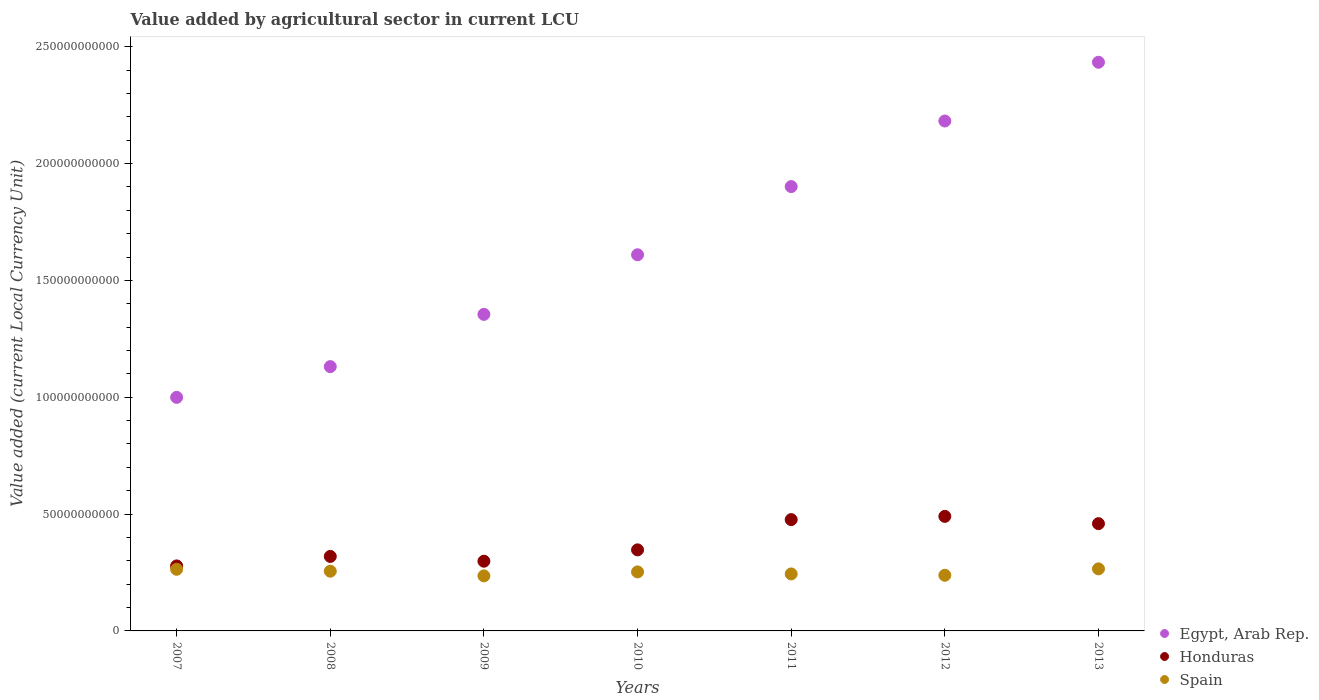How many different coloured dotlines are there?
Keep it short and to the point. 3. Is the number of dotlines equal to the number of legend labels?
Your answer should be compact. Yes. What is the value added by agricultural sector in Spain in 2012?
Provide a succinct answer. 2.38e+1. Across all years, what is the maximum value added by agricultural sector in Honduras?
Offer a very short reply. 4.90e+1. Across all years, what is the minimum value added by agricultural sector in Honduras?
Give a very brief answer. 2.78e+1. In which year was the value added by agricultural sector in Spain maximum?
Your answer should be compact. 2013. In which year was the value added by agricultural sector in Spain minimum?
Offer a very short reply. 2009. What is the total value added by agricultural sector in Egypt, Arab Rep. in the graph?
Your answer should be compact. 1.16e+12. What is the difference between the value added by agricultural sector in Egypt, Arab Rep. in 2007 and that in 2012?
Your answer should be very brief. -1.18e+11. What is the difference between the value added by agricultural sector in Egypt, Arab Rep. in 2013 and the value added by agricultural sector in Spain in 2008?
Provide a succinct answer. 2.18e+11. What is the average value added by agricultural sector in Honduras per year?
Give a very brief answer. 3.81e+1. In the year 2010, what is the difference between the value added by agricultural sector in Egypt, Arab Rep. and value added by agricultural sector in Spain?
Ensure brevity in your answer.  1.36e+11. In how many years, is the value added by agricultural sector in Honduras greater than 220000000000 LCU?
Offer a terse response. 0. What is the ratio of the value added by agricultural sector in Honduras in 2010 to that in 2013?
Your answer should be compact. 0.76. What is the difference between the highest and the second highest value added by agricultural sector in Honduras?
Ensure brevity in your answer.  1.38e+09. What is the difference between the highest and the lowest value added by agricultural sector in Honduras?
Your answer should be compact. 2.12e+1. In how many years, is the value added by agricultural sector in Honduras greater than the average value added by agricultural sector in Honduras taken over all years?
Offer a terse response. 3. Is it the case that in every year, the sum of the value added by agricultural sector in Honduras and value added by agricultural sector in Egypt, Arab Rep.  is greater than the value added by agricultural sector in Spain?
Ensure brevity in your answer.  Yes. Is the value added by agricultural sector in Spain strictly greater than the value added by agricultural sector in Honduras over the years?
Provide a short and direct response. No. How many years are there in the graph?
Offer a very short reply. 7. What is the difference between two consecutive major ticks on the Y-axis?
Offer a terse response. 5.00e+1. Does the graph contain any zero values?
Make the answer very short. No. Where does the legend appear in the graph?
Ensure brevity in your answer.  Bottom right. How many legend labels are there?
Offer a terse response. 3. What is the title of the graph?
Your answer should be compact. Value added by agricultural sector in current LCU. Does "United Arab Emirates" appear as one of the legend labels in the graph?
Provide a succinct answer. No. What is the label or title of the X-axis?
Ensure brevity in your answer.  Years. What is the label or title of the Y-axis?
Your answer should be compact. Value added (current Local Currency Unit). What is the Value added (current Local Currency Unit) in Egypt, Arab Rep. in 2007?
Provide a succinct answer. 1.00e+11. What is the Value added (current Local Currency Unit) of Honduras in 2007?
Make the answer very short. 2.78e+1. What is the Value added (current Local Currency Unit) in Spain in 2007?
Keep it short and to the point. 2.64e+1. What is the Value added (current Local Currency Unit) in Egypt, Arab Rep. in 2008?
Provide a succinct answer. 1.13e+11. What is the Value added (current Local Currency Unit) in Honduras in 2008?
Offer a very short reply. 3.19e+1. What is the Value added (current Local Currency Unit) of Spain in 2008?
Your answer should be compact. 2.56e+1. What is the Value added (current Local Currency Unit) in Egypt, Arab Rep. in 2009?
Provide a short and direct response. 1.35e+11. What is the Value added (current Local Currency Unit) of Honduras in 2009?
Make the answer very short. 2.98e+1. What is the Value added (current Local Currency Unit) in Spain in 2009?
Offer a terse response. 2.35e+1. What is the Value added (current Local Currency Unit) of Egypt, Arab Rep. in 2010?
Provide a short and direct response. 1.61e+11. What is the Value added (current Local Currency Unit) in Honduras in 2010?
Your answer should be compact. 3.47e+1. What is the Value added (current Local Currency Unit) in Spain in 2010?
Keep it short and to the point. 2.53e+1. What is the Value added (current Local Currency Unit) of Egypt, Arab Rep. in 2011?
Your answer should be compact. 1.90e+11. What is the Value added (current Local Currency Unit) of Honduras in 2011?
Offer a terse response. 4.76e+1. What is the Value added (current Local Currency Unit) in Spain in 2011?
Provide a succinct answer. 2.44e+1. What is the Value added (current Local Currency Unit) of Egypt, Arab Rep. in 2012?
Your response must be concise. 2.18e+11. What is the Value added (current Local Currency Unit) in Honduras in 2012?
Make the answer very short. 4.90e+1. What is the Value added (current Local Currency Unit) in Spain in 2012?
Offer a terse response. 2.38e+1. What is the Value added (current Local Currency Unit) in Egypt, Arab Rep. in 2013?
Your response must be concise. 2.43e+11. What is the Value added (current Local Currency Unit) in Honduras in 2013?
Your answer should be very brief. 4.59e+1. What is the Value added (current Local Currency Unit) of Spain in 2013?
Offer a very short reply. 2.66e+1. Across all years, what is the maximum Value added (current Local Currency Unit) in Egypt, Arab Rep.?
Your response must be concise. 2.43e+11. Across all years, what is the maximum Value added (current Local Currency Unit) of Honduras?
Provide a short and direct response. 4.90e+1. Across all years, what is the maximum Value added (current Local Currency Unit) of Spain?
Make the answer very short. 2.66e+1. Across all years, what is the minimum Value added (current Local Currency Unit) in Egypt, Arab Rep.?
Keep it short and to the point. 1.00e+11. Across all years, what is the minimum Value added (current Local Currency Unit) of Honduras?
Make the answer very short. 2.78e+1. Across all years, what is the minimum Value added (current Local Currency Unit) in Spain?
Give a very brief answer. 2.35e+1. What is the total Value added (current Local Currency Unit) of Egypt, Arab Rep. in the graph?
Give a very brief answer. 1.16e+12. What is the total Value added (current Local Currency Unit) of Honduras in the graph?
Ensure brevity in your answer.  2.67e+11. What is the total Value added (current Local Currency Unit) in Spain in the graph?
Keep it short and to the point. 1.76e+11. What is the difference between the Value added (current Local Currency Unit) of Egypt, Arab Rep. in 2007 and that in 2008?
Ensure brevity in your answer.  -1.32e+1. What is the difference between the Value added (current Local Currency Unit) of Honduras in 2007 and that in 2008?
Keep it short and to the point. -4.06e+09. What is the difference between the Value added (current Local Currency Unit) in Spain in 2007 and that in 2008?
Offer a terse response. 8.15e+08. What is the difference between the Value added (current Local Currency Unit) in Egypt, Arab Rep. in 2007 and that in 2009?
Provide a succinct answer. -3.55e+1. What is the difference between the Value added (current Local Currency Unit) of Honduras in 2007 and that in 2009?
Your response must be concise. -2.02e+09. What is the difference between the Value added (current Local Currency Unit) of Spain in 2007 and that in 2009?
Your answer should be very brief. 2.83e+09. What is the difference between the Value added (current Local Currency Unit) of Egypt, Arab Rep. in 2007 and that in 2010?
Offer a terse response. -6.10e+1. What is the difference between the Value added (current Local Currency Unit) in Honduras in 2007 and that in 2010?
Give a very brief answer. -6.87e+09. What is the difference between the Value added (current Local Currency Unit) of Spain in 2007 and that in 2010?
Make the answer very short. 1.12e+09. What is the difference between the Value added (current Local Currency Unit) of Egypt, Arab Rep. in 2007 and that in 2011?
Make the answer very short. -9.02e+1. What is the difference between the Value added (current Local Currency Unit) in Honduras in 2007 and that in 2011?
Keep it short and to the point. -1.98e+1. What is the difference between the Value added (current Local Currency Unit) of Spain in 2007 and that in 2011?
Your response must be concise. 1.98e+09. What is the difference between the Value added (current Local Currency Unit) in Egypt, Arab Rep. in 2007 and that in 2012?
Provide a succinct answer. -1.18e+11. What is the difference between the Value added (current Local Currency Unit) of Honduras in 2007 and that in 2012?
Your answer should be very brief. -2.12e+1. What is the difference between the Value added (current Local Currency Unit) in Spain in 2007 and that in 2012?
Your answer should be compact. 2.56e+09. What is the difference between the Value added (current Local Currency Unit) in Egypt, Arab Rep. in 2007 and that in 2013?
Ensure brevity in your answer.  -1.43e+11. What is the difference between the Value added (current Local Currency Unit) in Honduras in 2007 and that in 2013?
Keep it short and to the point. -1.81e+1. What is the difference between the Value added (current Local Currency Unit) in Spain in 2007 and that in 2013?
Provide a succinct answer. -1.84e+08. What is the difference between the Value added (current Local Currency Unit) of Egypt, Arab Rep. in 2008 and that in 2009?
Ensure brevity in your answer.  -2.24e+1. What is the difference between the Value added (current Local Currency Unit) in Honduras in 2008 and that in 2009?
Give a very brief answer. 2.05e+09. What is the difference between the Value added (current Local Currency Unit) in Spain in 2008 and that in 2009?
Your answer should be very brief. 2.01e+09. What is the difference between the Value added (current Local Currency Unit) in Egypt, Arab Rep. in 2008 and that in 2010?
Ensure brevity in your answer.  -4.79e+1. What is the difference between the Value added (current Local Currency Unit) in Honduras in 2008 and that in 2010?
Give a very brief answer. -2.81e+09. What is the difference between the Value added (current Local Currency Unit) in Spain in 2008 and that in 2010?
Keep it short and to the point. 3.08e+08. What is the difference between the Value added (current Local Currency Unit) of Egypt, Arab Rep. in 2008 and that in 2011?
Offer a very short reply. -7.71e+1. What is the difference between the Value added (current Local Currency Unit) of Honduras in 2008 and that in 2011?
Give a very brief answer. -1.58e+1. What is the difference between the Value added (current Local Currency Unit) in Spain in 2008 and that in 2011?
Offer a terse response. 1.17e+09. What is the difference between the Value added (current Local Currency Unit) of Egypt, Arab Rep. in 2008 and that in 2012?
Your response must be concise. -1.05e+11. What is the difference between the Value added (current Local Currency Unit) of Honduras in 2008 and that in 2012?
Your answer should be very brief. -1.71e+1. What is the difference between the Value added (current Local Currency Unit) in Spain in 2008 and that in 2012?
Provide a short and direct response. 1.74e+09. What is the difference between the Value added (current Local Currency Unit) in Egypt, Arab Rep. in 2008 and that in 2013?
Ensure brevity in your answer.  -1.30e+11. What is the difference between the Value added (current Local Currency Unit) of Honduras in 2008 and that in 2013?
Offer a very short reply. -1.40e+1. What is the difference between the Value added (current Local Currency Unit) of Spain in 2008 and that in 2013?
Offer a terse response. -9.99e+08. What is the difference between the Value added (current Local Currency Unit) of Egypt, Arab Rep. in 2009 and that in 2010?
Your answer should be compact. -2.55e+1. What is the difference between the Value added (current Local Currency Unit) of Honduras in 2009 and that in 2010?
Make the answer very short. -4.85e+09. What is the difference between the Value added (current Local Currency Unit) in Spain in 2009 and that in 2010?
Keep it short and to the point. -1.70e+09. What is the difference between the Value added (current Local Currency Unit) in Egypt, Arab Rep. in 2009 and that in 2011?
Provide a short and direct response. -5.47e+1. What is the difference between the Value added (current Local Currency Unit) of Honduras in 2009 and that in 2011?
Keep it short and to the point. -1.78e+1. What is the difference between the Value added (current Local Currency Unit) of Spain in 2009 and that in 2011?
Your answer should be compact. -8.42e+08. What is the difference between the Value added (current Local Currency Unit) in Egypt, Arab Rep. in 2009 and that in 2012?
Your response must be concise. -8.28e+1. What is the difference between the Value added (current Local Currency Unit) in Honduras in 2009 and that in 2012?
Ensure brevity in your answer.  -1.92e+1. What is the difference between the Value added (current Local Currency Unit) of Spain in 2009 and that in 2012?
Your answer should be very brief. -2.68e+08. What is the difference between the Value added (current Local Currency Unit) in Egypt, Arab Rep. in 2009 and that in 2013?
Ensure brevity in your answer.  -1.08e+11. What is the difference between the Value added (current Local Currency Unit) of Honduras in 2009 and that in 2013?
Provide a short and direct response. -1.61e+1. What is the difference between the Value added (current Local Currency Unit) in Spain in 2009 and that in 2013?
Your answer should be very brief. -3.01e+09. What is the difference between the Value added (current Local Currency Unit) of Egypt, Arab Rep. in 2010 and that in 2011?
Provide a succinct answer. -2.92e+1. What is the difference between the Value added (current Local Currency Unit) in Honduras in 2010 and that in 2011?
Make the answer very short. -1.29e+1. What is the difference between the Value added (current Local Currency Unit) in Spain in 2010 and that in 2011?
Make the answer very short. 8.62e+08. What is the difference between the Value added (current Local Currency Unit) in Egypt, Arab Rep. in 2010 and that in 2012?
Your answer should be very brief. -5.72e+1. What is the difference between the Value added (current Local Currency Unit) of Honduras in 2010 and that in 2012?
Offer a terse response. -1.43e+1. What is the difference between the Value added (current Local Currency Unit) in Spain in 2010 and that in 2012?
Provide a short and direct response. 1.44e+09. What is the difference between the Value added (current Local Currency Unit) of Egypt, Arab Rep. in 2010 and that in 2013?
Your response must be concise. -8.24e+1. What is the difference between the Value added (current Local Currency Unit) in Honduras in 2010 and that in 2013?
Make the answer very short. -1.12e+1. What is the difference between the Value added (current Local Currency Unit) in Spain in 2010 and that in 2013?
Give a very brief answer. -1.31e+09. What is the difference between the Value added (current Local Currency Unit) of Egypt, Arab Rep. in 2011 and that in 2012?
Your response must be concise. -2.81e+1. What is the difference between the Value added (current Local Currency Unit) of Honduras in 2011 and that in 2012?
Your response must be concise. -1.38e+09. What is the difference between the Value added (current Local Currency Unit) of Spain in 2011 and that in 2012?
Offer a terse response. 5.74e+08. What is the difference between the Value added (current Local Currency Unit) in Egypt, Arab Rep. in 2011 and that in 2013?
Offer a very short reply. -5.32e+1. What is the difference between the Value added (current Local Currency Unit) in Honduras in 2011 and that in 2013?
Your response must be concise. 1.74e+09. What is the difference between the Value added (current Local Currency Unit) of Spain in 2011 and that in 2013?
Your answer should be compact. -2.17e+09. What is the difference between the Value added (current Local Currency Unit) of Egypt, Arab Rep. in 2012 and that in 2013?
Make the answer very short. -2.51e+1. What is the difference between the Value added (current Local Currency Unit) of Honduras in 2012 and that in 2013?
Give a very brief answer. 3.12e+09. What is the difference between the Value added (current Local Currency Unit) in Spain in 2012 and that in 2013?
Ensure brevity in your answer.  -2.74e+09. What is the difference between the Value added (current Local Currency Unit) of Egypt, Arab Rep. in 2007 and the Value added (current Local Currency Unit) of Honduras in 2008?
Offer a very short reply. 6.81e+1. What is the difference between the Value added (current Local Currency Unit) in Egypt, Arab Rep. in 2007 and the Value added (current Local Currency Unit) in Spain in 2008?
Your answer should be very brief. 7.44e+1. What is the difference between the Value added (current Local Currency Unit) of Honduras in 2007 and the Value added (current Local Currency Unit) of Spain in 2008?
Your answer should be compact. 2.26e+09. What is the difference between the Value added (current Local Currency Unit) in Egypt, Arab Rep. in 2007 and the Value added (current Local Currency Unit) in Honduras in 2009?
Ensure brevity in your answer.  7.01e+1. What is the difference between the Value added (current Local Currency Unit) of Egypt, Arab Rep. in 2007 and the Value added (current Local Currency Unit) of Spain in 2009?
Provide a short and direct response. 7.64e+1. What is the difference between the Value added (current Local Currency Unit) of Honduras in 2007 and the Value added (current Local Currency Unit) of Spain in 2009?
Your answer should be very brief. 4.27e+09. What is the difference between the Value added (current Local Currency Unit) in Egypt, Arab Rep. in 2007 and the Value added (current Local Currency Unit) in Honduras in 2010?
Your answer should be very brief. 6.53e+1. What is the difference between the Value added (current Local Currency Unit) in Egypt, Arab Rep. in 2007 and the Value added (current Local Currency Unit) in Spain in 2010?
Your response must be concise. 7.47e+1. What is the difference between the Value added (current Local Currency Unit) of Honduras in 2007 and the Value added (current Local Currency Unit) of Spain in 2010?
Provide a succinct answer. 2.57e+09. What is the difference between the Value added (current Local Currency Unit) of Egypt, Arab Rep. in 2007 and the Value added (current Local Currency Unit) of Honduras in 2011?
Provide a succinct answer. 5.23e+1. What is the difference between the Value added (current Local Currency Unit) in Egypt, Arab Rep. in 2007 and the Value added (current Local Currency Unit) in Spain in 2011?
Offer a very short reply. 7.56e+1. What is the difference between the Value added (current Local Currency Unit) of Honduras in 2007 and the Value added (current Local Currency Unit) of Spain in 2011?
Provide a short and direct response. 3.43e+09. What is the difference between the Value added (current Local Currency Unit) of Egypt, Arab Rep. in 2007 and the Value added (current Local Currency Unit) of Honduras in 2012?
Your answer should be compact. 5.09e+1. What is the difference between the Value added (current Local Currency Unit) in Egypt, Arab Rep. in 2007 and the Value added (current Local Currency Unit) in Spain in 2012?
Offer a very short reply. 7.61e+1. What is the difference between the Value added (current Local Currency Unit) of Honduras in 2007 and the Value added (current Local Currency Unit) of Spain in 2012?
Your answer should be compact. 4.00e+09. What is the difference between the Value added (current Local Currency Unit) in Egypt, Arab Rep. in 2007 and the Value added (current Local Currency Unit) in Honduras in 2013?
Keep it short and to the point. 5.40e+1. What is the difference between the Value added (current Local Currency Unit) in Egypt, Arab Rep. in 2007 and the Value added (current Local Currency Unit) in Spain in 2013?
Keep it short and to the point. 7.34e+1. What is the difference between the Value added (current Local Currency Unit) of Honduras in 2007 and the Value added (current Local Currency Unit) of Spain in 2013?
Your response must be concise. 1.26e+09. What is the difference between the Value added (current Local Currency Unit) in Egypt, Arab Rep. in 2008 and the Value added (current Local Currency Unit) in Honduras in 2009?
Your answer should be very brief. 8.33e+1. What is the difference between the Value added (current Local Currency Unit) in Egypt, Arab Rep. in 2008 and the Value added (current Local Currency Unit) in Spain in 2009?
Ensure brevity in your answer.  8.96e+1. What is the difference between the Value added (current Local Currency Unit) in Honduras in 2008 and the Value added (current Local Currency Unit) in Spain in 2009?
Your response must be concise. 8.34e+09. What is the difference between the Value added (current Local Currency Unit) in Egypt, Arab Rep. in 2008 and the Value added (current Local Currency Unit) in Honduras in 2010?
Your response must be concise. 7.84e+1. What is the difference between the Value added (current Local Currency Unit) of Egypt, Arab Rep. in 2008 and the Value added (current Local Currency Unit) of Spain in 2010?
Keep it short and to the point. 8.79e+1. What is the difference between the Value added (current Local Currency Unit) in Honduras in 2008 and the Value added (current Local Currency Unit) in Spain in 2010?
Your answer should be very brief. 6.63e+09. What is the difference between the Value added (current Local Currency Unit) of Egypt, Arab Rep. in 2008 and the Value added (current Local Currency Unit) of Honduras in 2011?
Provide a short and direct response. 6.55e+1. What is the difference between the Value added (current Local Currency Unit) of Egypt, Arab Rep. in 2008 and the Value added (current Local Currency Unit) of Spain in 2011?
Give a very brief answer. 8.87e+1. What is the difference between the Value added (current Local Currency Unit) in Honduras in 2008 and the Value added (current Local Currency Unit) in Spain in 2011?
Ensure brevity in your answer.  7.49e+09. What is the difference between the Value added (current Local Currency Unit) of Egypt, Arab Rep. in 2008 and the Value added (current Local Currency Unit) of Honduras in 2012?
Your answer should be compact. 6.41e+1. What is the difference between the Value added (current Local Currency Unit) in Egypt, Arab Rep. in 2008 and the Value added (current Local Currency Unit) in Spain in 2012?
Keep it short and to the point. 8.93e+1. What is the difference between the Value added (current Local Currency Unit) in Honduras in 2008 and the Value added (current Local Currency Unit) in Spain in 2012?
Your answer should be very brief. 8.07e+09. What is the difference between the Value added (current Local Currency Unit) of Egypt, Arab Rep. in 2008 and the Value added (current Local Currency Unit) of Honduras in 2013?
Give a very brief answer. 6.72e+1. What is the difference between the Value added (current Local Currency Unit) of Egypt, Arab Rep. in 2008 and the Value added (current Local Currency Unit) of Spain in 2013?
Your answer should be very brief. 8.65e+1. What is the difference between the Value added (current Local Currency Unit) of Honduras in 2008 and the Value added (current Local Currency Unit) of Spain in 2013?
Your response must be concise. 5.32e+09. What is the difference between the Value added (current Local Currency Unit) of Egypt, Arab Rep. in 2009 and the Value added (current Local Currency Unit) of Honduras in 2010?
Keep it short and to the point. 1.01e+11. What is the difference between the Value added (current Local Currency Unit) of Egypt, Arab Rep. in 2009 and the Value added (current Local Currency Unit) of Spain in 2010?
Provide a succinct answer. 1.10e+11. What is the difference between the Value added (current Local Currency Unit) in Honduras in 2009 and the Value added (current Local Currency Unit) in Spain in 2010?
Ensure brevity in your answer.  4.58e+09. What is the difference between the Value added (current Local Currency Unit) in Egypt, Arab Rep. in 2009 and the Value added (current Local Currency Unit) in Honduras in 2011?
Your answer should be compact. 8.78e+1. What is the difference between the Value added (current Local Currency Unit) of Egypt, Arab Rep. in 2009 and the Value added (current Local Currency Unit) of Spain in 2011?
Your response must be concise. 1.11e+11. What is the difference between the Value added (current Local Currency Unit) of Honduras in 2009 and the Value added (current Local Currency Unit) of Spain in 2011?
Provide a succinct answer. 5.45e+09. What is the difference between the Value added (current Local Currency Unit) of Egypt, Arab Rep. in 2009 and the Value added (current Local Currency Unit) of Honduras in 2012?
Offer a very short reply. 8.64e+1. What is the difference between the Value added (current Local Currency Unit) of Egypt, Arab Rep. in 2009 and the Value added (current Local Currency Unit) of Spain in 2012?
Your response must be concise. 1.12e+11. What is the difference between the Value added (current Local Currency Unit) in Honduras in 2009 and the Value added (current Local Currency Unit) in Spain in 2012?
Ensure brevity in your answer.  6.02e+09. What is the difference between the Value added (current Local Currency Unit) in Egypt, Arab Rep. in 2009 and the Value added (current Local Currency Unit) in Honduras in 2013?
Your answer should be very brief. 8.96e+1. What is the difference between the Value added (current Local Currency Unit) in Egypt, Arab Rep. in 2009 and the Value added (current Local Currency Unit) in Spain in 2013?
Offer a terse response. 1.09e+11. What is the difference between the Value added (current Local Currency Unit) in Honduras in 2009 and the Value added (current Local Currency Unit) in Spain in 2013?
Provide a succinct answer. 3.28e+09. What is the difference between the Value added (current Local Currency Unit) of Egypt, Arab Rep. in 2010 and the Value added (current Local Currency Unit) of Honduras in 2011?
Offer a terse response. 1.13e+11. What is the difference between the Value added (current Local Currency Unit) of Egypt, Arab Rep. in 2010 and the Value added (current Local Currency Unit) of Spain in 2011?
Ensure brevity in your answer.  1.37e+11. What is the difference between the Value added (current Local Currency Unit) in Honduras in 2010 and the Value added (current Local Currency Unit) in Spain in 2011?
Ensure brevity in your answer.  1.03e+1. What is the difference between the Value added (current Local Currency Unit) in Egypt, Arab Rep. in 2010 and the Value added (current Local Currency Unit) in Honduras in 2012?
Provide a succinct answer. 1.12e+11. What is the difference between the Value added (current Local Currency Unit) in Egypt, Arab Rep. in 2010 and the Value added (current Local Currency Unit) in Spain in 2012?
Ensure brevity in your answer.  1.37e+11. What is the difference between the Value added (current Local Currency Unit) of Honduras in 2010 and the Value added (current Local Currency Unit) of Spain in 2012?
Ensure brevity in your answer.  1.09e+1. What is the difference between the Value added (current Local Currency Unit) in Egypt, Arab Rep. in 2010 and the Value added (current Local Currency Unit) in Honduras in 2013?
Provide a succinct answer. 1.15e+11. What is the difference between the Value added (current Local Currency Unit) in Egypt, Arab Rep. in 2010 and the Value added (current Local Currency Unit) in Spain in 2013?
Keep it short and to the point. 1.34e+11. What is the difference between the Value added (current Local Currency Unit) of Honduras in 2010 and the Value added (current Local Currency Unit) of Spain in 2013?
Offer a terse response. 8.13e+09. What is the difference between the Value added (current Local Currency Unit) of Egypt, Arab Rep. in 2011 and the Value added (current Local Currency Unit) of Honduras in 2012?
Make the answer very short. 1.41e+11. What is the difference between the Value added (current Local Currency Unit) in Egypt, Arab Rep. in 2011 and the Value added (current Local Currency Unit) in Spain in 2012?
Keep it short and to the point. 1.66e+11. What is the difference between the Value added (current Local Currency Unit) in Honduras in 2011 and the Value added (current Local Currency Unit) in Spain in 2012?
Offer a terse response. 2.38e+1. What is the difference between the Value added (current Local Currency Unit) in Egypt, Arab Rep. in 2011 and the Value added (current Local Currency Unit) in Honduras in 2013?
Provide a short and direct response. 1.44e+11. What is the difference between the Value added (current Local Currency Unit) of Egypt, Arab Rep. in 2011 and the Value added (current Local Currency Unit) of Spain in 2013?
Your response must be concise. 1.64e+11. What is the difference between the Value added (current Local Currency Unit) of Honduras in 2011 and the Value added (current Local Currency Unit) of Spain in 2013?
Your answer should be compact. 2.11e+1. What is the difference between the Value added (current Local Currency Unit) in Egypt, Arab Rep. in 2012 and the Value added (current Local Currency Unit) in Honduras in 2013?
Keep it short and to the point. 1.72e+11. What is the difference between the Value added (current Local Currency Unit) in Egypt, Arab Rep. in 2012 and the Value added (current Local Currency Unit) in Spain in 2013?
Provide a succinct answer. 1.92e+11. What is the difference between the Value added (current Local Currency Unit) in Honduras in 2012 and the Value added (current Local Currency Unit) in Spain in 2013?
Your response must be concise. 2.25e+1. What is the average Value added (current Local Currency Unit) in Egypt, Arab Rep. per year?
Make the answer very short. 1.66e+11. What is the average Value added (current Local Currency Unit) in Honduras per year?
Your answer should be very brief. 3.81e+1. What is the average Value added (current Local Currency Unit) of Spain per year?
Provide a short and direct response. 2.51e+1. In the year 2007, what is the difference between the Value added (current Local Currency Unit) of Egypt, Arab Rep. and Value added (current Local Currency Unit) of Honduras?
Offer a terse response. 7.21e+1. In the year 2007, what is the difference between the Value added (current Local Currency Unit) of Egypt, Arab Rep. and Value added (current Local Currency Unit) of Spain?
Ensure brevity in your answer.  7.36e+1. In the year 2007, what is the difference between the Value added (current Local Currency Unit) of Honduras and Value added (current Local Currency Unit) of Spain?
Offer a very short reply. 1.44e+09. In the year 2008, what is the difference between the Value added (current Local Currency Unit) of Egypt, Arab Rep. and Value added (current Local Currency Unit) of Honduras?
Give a very brief answer. 8.12e+1. In the year 2008, what is the difference between the Value added (current Local Currency Unit) of Egypt, Arab Rep. and Value added (current Local Currency Unit) of Spain?
Give a very brief answer. 8.75e+1. In the year 2008, what is the difference between the Value added (current Local Currency Unit) of Honduras and Value added (current Local Currency Unit) of Spain?
Your response must be concise. 6.32e+09. In the year 2009, what is the difference between the Value added (current Local Currency Unit) in Egypt, Arab Rep. and Value added (current Local Currency Unit) in Honduras?
Your answer should be very brief. 1.06e+11. In the year 2009, what is the difference between the Value added (current Local Currency Unit) of Egypt, Arab Rep. and Value added (current Local Currency Unit) of Spain?
Keep it short and to the point. 1.12e+11. In the year 2009, what is the difference between the Value added (current Local Currency Unit) in Honduras and Value added (current Local Currency Unit) in Spain?
Your response must be concise. 6.29e+09. In the year 2010, what is the difference between the Value added (current Local Currency Unit) in Egypt, Arab Rep. and Value added (current Local Currency Unit) in Honduras?
Offer a very short reply. 1.26e+11. In the year 2010, what is the difference between the Value added (current Local Currency Unit) in Egypt, Arab Rep. and Value added (current Local Currency Unit) in Spain?
Ensure brevity in your answer.  1.36e+11. In the year 2010, what is the difference between the Value added (current Local Currency Unit) in Honduras and Value added (current Local Currency Unit) in Spain?
Keep it short and to the point. 9.44e+09. In the year 2011, what is the difference between the Value added (current Local Currency Unit) of Egypt, Arab Rep. and Value added (current Local Currency Unit) of Honduras?
Provide a succinct answer. 1.43e+11. In the year 2011, what is the difference between the Value added (current Local Currency Unit) of Egypt, Arab Rep. and Value added (current Local Currency Unit) of Spain?
Provide a succinct answer. 1.66e+11. In the year 2011, what is the difference between the Value added (current Local Currency Unit) of Honduras and Value added (current Local Currency Unit) of Spain?
Offer a terse response. 2.32e+1. In the year 2012, what is the difference between the Value added (current Local Currency Unit) of Egypt, Arab Rep. and Value added (current Local Currency Unit) of Honduras?
Your answer should be very brief. 1.69e+11. In the year 2012, what is the difference between the Value added (current Local Currency Unit) in Egypt, Arab Rep. and Value added (current Local Currency Unit) in Spain?
Provide a short and direct response. 1.94e+11. In the year 2012, what is the difference between the Value added (current Local Currency Unit) in Honduras and Value added (current Local Currency Unit) in Spain?
Your response must be concise. 2.52e+1. In the year 2013, what is the difference between the Value added (current Local Currency Unit) of Egypt, Arab Rep. and Value added (current Local Currency Unit) of Honduras?
Offer a terse response. 1.97e+11. In the year 2013, what is the difference between the Value added (current Local Currency Unit) in Egypt, Arab Rep. and Value added (current Local Currency Unit) in Spain?
Provide a short and direct response. 2.17e+11. In the year 2013, what is the difference between the Value added (current Local Currency Unit) in Honduras and Value added (current Local Currency Unit) in Spain?
Make the answer very short. 1.93e+1. What is the ratio of the Value added (current Local Currency Unit) of Egypt, Arab Rep. in 2007 to that in 2008?
Make the answer very short. 0.88. What is the ratio of the Value added (current Local Currency Unit) of Honduras in 2007 to that in 2008?
Your answer should be compact. 0.87. What is the ratio of the Value added (current Local Currency Unit) in Spain in 2007 to that in 2008?
Your answer should be compact. 1.03. What is the ratio of the Value added (current Local Currency Unit) in Egypt, Arab Rep. in 2007 to that in 2009?
Provide a succinct answer. 0.74. What is the ratio of the Value added (current Local Currency Unit) in Honduras in 2007 to that in 2009?
Ensure brevity in your answer.  0.93. What is the ratio of the Value added (current Local Currency Unit) of Spain in 2007 to that in 2009?
Offer a terse response. 1.12. What is the ratio of the Value added (current Local Currency Unit) of Egypt, Arab Rep. in 2007 to that in 2010?
Make the answer very short. 0.62. What is the ratio of the Value added (current Local Currency Unit) of Honduras in 2007 to that in 2010?
Provide a short and direct response. 0.8. What is the ratio of the Value added (current Local Currency Unit) in Spain in 2007 to that in 2010?
Make the answer very short. 1.04. What is the ratio of the Value added (current Local Currency Unit) of Egypt, Arab Rep. in 2007 to that in 2011?
Offer a very short reply. 0.53. What is the ratio of the Value added (current Local Currency Unit) of Honduras in 2007 to that in 2011?
Ensure brevity in your answer.  0.58. What is the ratio of the Value added (current Local Currency Unit) of Spain in 2007 to that in 2011?
Give a very brief answer. 1.08. What is the ratio of the Value added (current Local Currency Unit) of Egypt, Arab Rep. in 2007 to that in 2012?
Your answer should be very brief. 0.46. What is the ratio of the Value added (current Local Currency Unit) in Honduras in 2007 to that in 2012?
Give a very brief answer. 0.57. What is the ratio of the Value added (current Local Currency Unit) in Spain in 2007 to that in 2012?
Provide a short and direct response. 1.11. What is the ratio of the Value added (current Local Currency Unit) in Egypt, Arab Rep. in 2007 to that in 2013?
Make the answer very short. 0.41. What is the ratio of the Value added (current Local Currency Unit) of Honduras in 2007 to that in 2013?
Give a very brief answer. 0.61. What is the ratio of the Value added (current Local Currency Unit) in Spain in 2007 to that in 2013?
Keep it short and to the point. 0.99. What is the ratio of the Value added (current Local Currency Unit) in Egypt, Arab Rep. in 2008 to that in 2009?
Ensure brevity in your answer.  0.83. What is the ratio of the Value added (current Local Currency Unit) in Honduras in 2008 to that in 2009?
Keep it short and to the point. 1.07. What is the ratio of the Value added (current Local Currency Unit) of Spain in 2008 to that in 2009?
Ensure brevity in your answer.  1.09. What is the ratio of the Value added (current Local Currency Unit) of Egypt, Arab Rep. in 2008 to that in 2010?
Keep it short and to the point. 0.7. What is the ratio of the Value added (current Local Currency Unit) in Honduras in 2008 to that in 2010?
Your answer should be very brief. 0.92. What is the ratio of the Value added (current Local Currency Unit) in Spain in 2008 to that in 2010?
Your answer should be very brief. 1.01. What is the ratio of the Value added (current Local Currency Unit) of Egypt, Arab Rep. in 2008 to that in 2011?
Make the answer very short. 0.59. What is the ratio of the Value added (current Local Currency Unit) of Honduras in 2008 to that in 2011?
Make the answer very short. 0.67. What is the ratio of the Value added (current Local Currency Unit) in Spain in 2008 to that in 2011?
Your answer should be compact. 1.05. What is the ratio of the Value added (current Local Currency Unit) of Egypt, Arab Rep. in 2008 to that in 2012?
Your answer should be compact. 0.52. What is the ratio of the Value added (current Local Currency Unit) in Honduras in 2008 to that in 2012?
Your response must be concise. 0.65. What is the ratio of the Value added (current Local Currency Unit) in Spain in 2008 to that in 2012?
Give a very brief answer. 1.07. What is the ratio of the Value added (current Local Currency Unit) in Egypt, Arab Rep. in 2008 to that in 2013?
Ensure brevity in your answer.  0.46. What is the ratio of the Value added (current Local Currency Unit) of Honduras in 2008 to that in 2013?
Offer a terse response. 0.69. What is the ratio of the Value added (current Local Currency Unit) of Spain in 2008 to that in 2013?
Offer a terse response. 0.96. What is the ratio of the Value added (current Local Currency Unit) of Egypt, Arab Rep. in 2009 to that in 2010?
Your answer should be very brief. 0.84. What is the ratio of the Value added (current Local Currency Unit) in Honduras in 2009 to that in 2010?
Ensure brevity in your answer.  0.86. What is the ratio of the Value added (current Local Currency Unit) of Spain in 2009 to that in 2010?
Offer a very short reply. 0.93. What is the ratio of the Value added (current Local Currency Unit) of Egypt, Arab Rep. in 2009 to that in 2011?
Your response must be concise. 0.71. What is the ratio of the Value added (current Local Currency Unit) in Honduras in 2009 to that in 2011?
Offer a terse response. 0.63. What is the ratio of the Value added (current Local Currency Unit) in Spain in 2009 to that in 2011?
Your answer should be very brief. 0.97. What is the ratio of the Value added (current Local Currency Unit) of Egypt, Arab Rep. in 2009 to that in 2012?
Keep it short and to the point. 0.62. What is the ratio of the Value added (current Local Currency Unit) in Honduras in 2009 to that in 2012?
Your answer should be compact. 0.61. What is the ratio of the Value added (current Local Currency Unit) in Spain in 2009 to that in 2012?
Provide a succinct answer. 0.99. What is the ratio of the Value added (current Local Currency Unit) in Egypt, Arab Rep. in 2009 to that in 2013?
Offer a terse response. 0.56. What is the ratio of the Value added (current Local Currency Unit) of Honduras in 2009 to that in 2013?
Provide a succinct answer. 0.65. What is the ratio of the Value added (current Local Currency Unit) of Spain in 2009 to that in 2013?
Make the answer very short. 0.89. What is the ratio of the Value added (current Local Currency Unit) in Egypt, Arab Rep. in 2010 to that in 2011?
Make the answer very short. 0.85. What is the ratio of the Value added (current Local Currency Unit) of Honduras in 2010 to that in 2011?
Ensure brevity in your answer.  0.73. What is the ratio of the Value added (current Local Currency Unit) in Spain in 2010 to that in 2011?
Offer a very short reply. 1.04. What is the ratio of the Value added (current Local Currency Unit) in Egypt, Arab Rep. in 2010 to that in 2012?
Ensure brevity in your answer.  0.74. What is the ratio of the Value added (current Local Currency Unit) in Honduras in 2010 to that in 2012?
Your answer should be very brief. 0.71. What is the ratio of the Value added (current Local Currency Unit) in Spain in 2010 to that in 2012?
Ensure brevity in your answer.  1.06. What is the ratio of the Value added (current Local Currency Unit) of Egypt, Arab Rep. in 2010 to that in 2013?
Make the answer very short. 0.66. What is the ratio of the Value added (current Local Currency Unit) of Honduras in 2010 to that in 2013?
Provide a short and direct response. 0.76. What is the ratio of the Value added (current Local Currency Unit) of Spain in 2010 to that in 2013?
Your answer should be compact. 0.95. What is the ratio of the Value added (current Local Currency Unit) in Egypt, Arab Rep. in 2011 to that in 2012?
Offer a terse response. 0.87. What is the ratio of the Value added (current Local Currency Unit) of Honduras in 2011 to that in 2012?
Keep it short and to the point. 0.97. What is the ratio of the Value added (current Local Currency Unit) in Spain in 2011 to that in 2012?
Your answer should be compact. 1.02. What is the ratio of the Value added (current Local Currency Unit) of Egypt, Arab Rep. in 2011 to that in 2013?
Make the answer very short. 0.78. What is the ratio of the Value added (current Local Currency Unit) in Honduras in 2011 to that in 2013?
Give a very brief answer. 1.04. What is the ratio of the Value added (current Local Currency Unit) of Spain in 2011 to that in 2013?
Offer a very short reply. 0.92. What is the ratio of the Value added (current Local Currency Unit) in Egypt, Arab Rep. in 2012 to that in 2013?
Keep it short and to the point. 0.9. What is the ratio of the Value added (current Local Currency Unit) in Honduras in 2012 to that in 2013?
Offer a very short reply. 1.07. What is the ratio of the Value added (current Local Currency Unit) in Spain in 2012 to that in 2013?
Your response must be concise. 0.9. What is the difference between the highest and the second highest Value added (current Local Currency Unit) of Egypt, Arab Rep.?
Provide a succinct answer. 2.51e+1. What is the difference between the highest and the second highest Value added (current Local Currency Unit) in Honduras?
Make the answer very short. 1.38e+09. What is the difference between the highest and the second highest Value added (current Local Currency Unit) in Spain?
Your response must be concise. 1.84e+08. What is the difference between the highest and the lowest Value added (current Local Currency Unit) of Egypt, Arab Rep.?
Your response must be concise. 1.43e+11. What is the difference between the highest and the lowest Value added (current Local Currency Unit) in Honduras?
Your answer should be compact. 2.12e+1. What is the difference between the highest and the lowest Value added (current Local Currency Unit) of Spain?
Your answer should be very brief. 3.01e+09. 